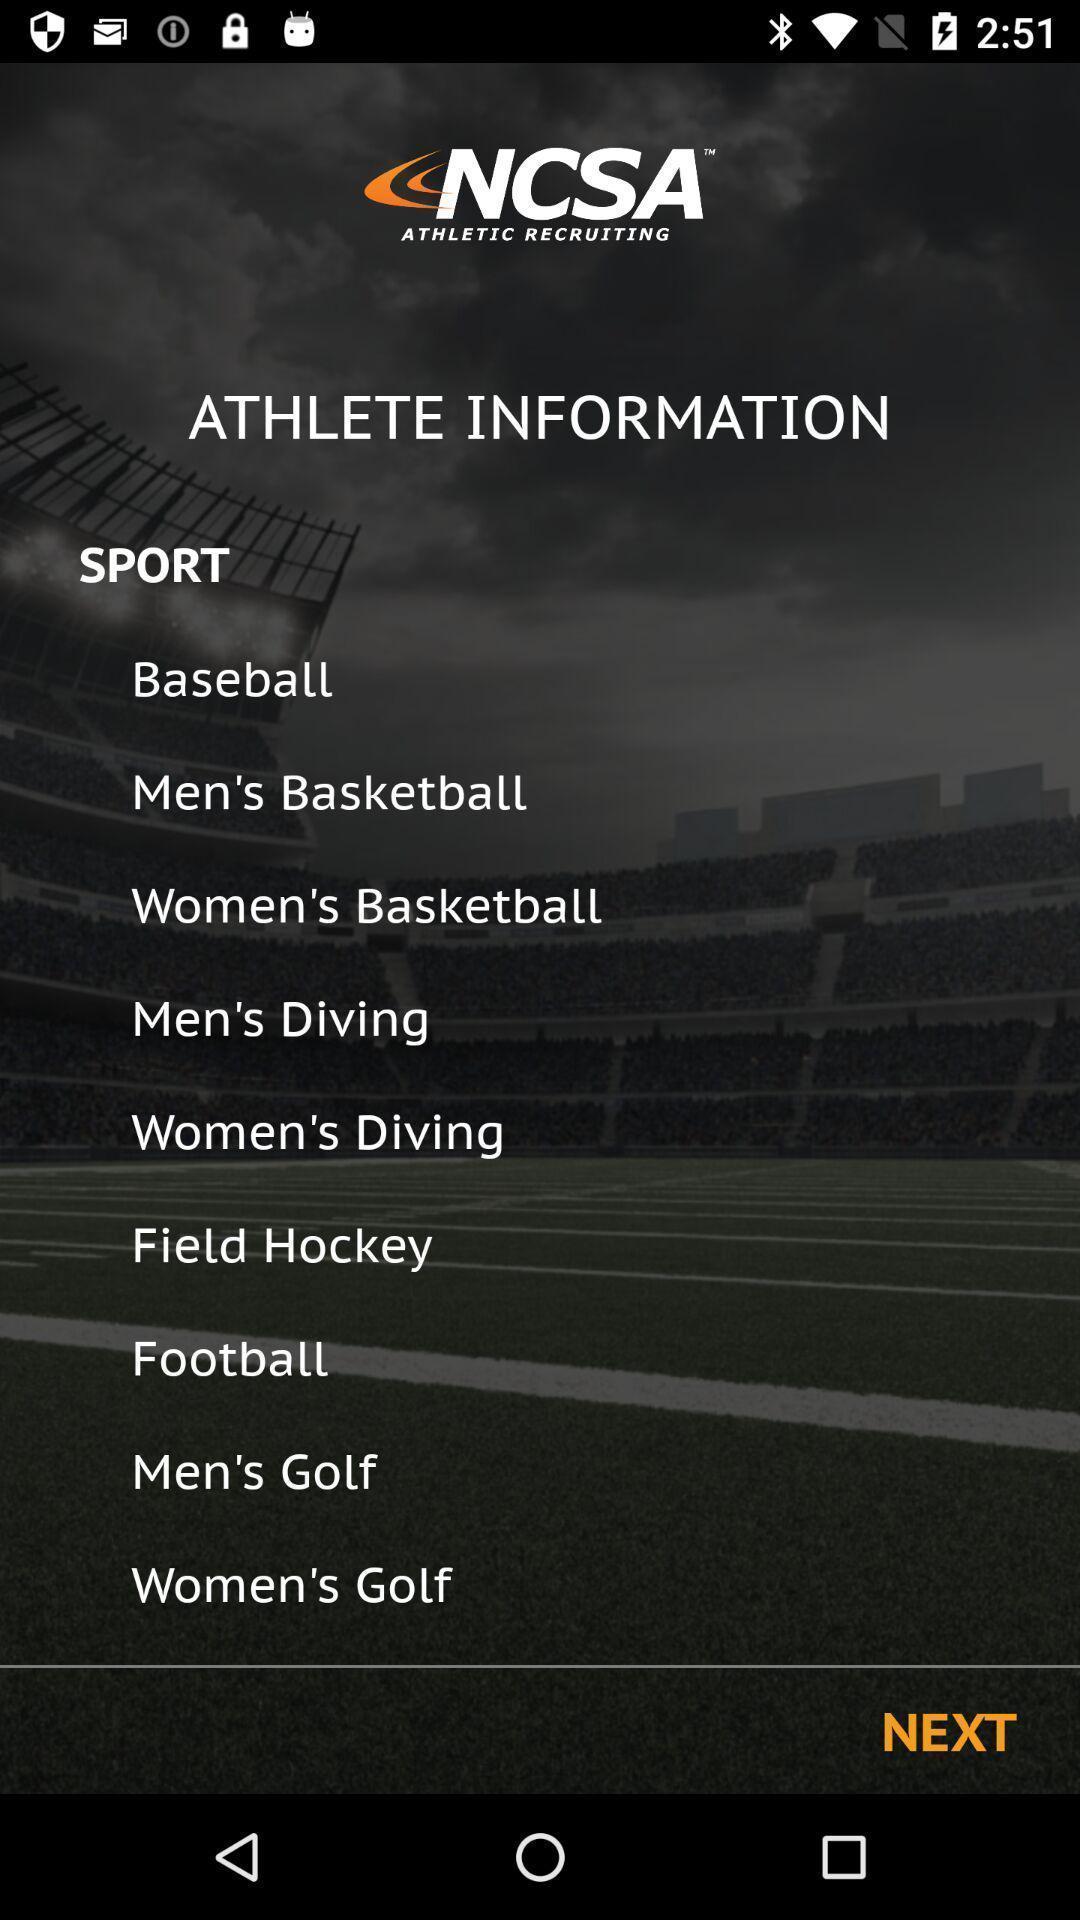Provide a description of this screenshot. Welcome page displaying different categories of sports in sports application. 